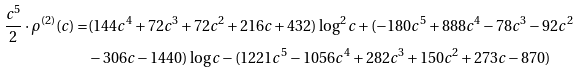<formula> <loc_0><loc_0><loc_500><loc_500>\frac { c ^ { 5 } } { 2 } \cdot \rho ^ { ( 2 ) } ( c ) = & ( 1 4 4 c ^ { 4 } + 7 2 c ^ { 3 } + 7 2 c ^ { 2 } + 2 1 6 c + 4 3 2 ) \log ^ { 2 } c + ( - 1 8 0 c ^ { 5 } + 8 8 8 c ^ { 4 } - 7 8 c ^ { 3 } - 9 2 c ^ { 2 } \\ & - 3 0 6 c - 1 4 4 0 ) \log c - ( 1 2 2 1 c ^ { 5 } - 1 0 5 6 c ^ { 4 } + 2 8 2 c ^ { 3 } + 1 5 0 c ^ { 2 } + 2 7 3 c - 8 7 0 )</formula> 